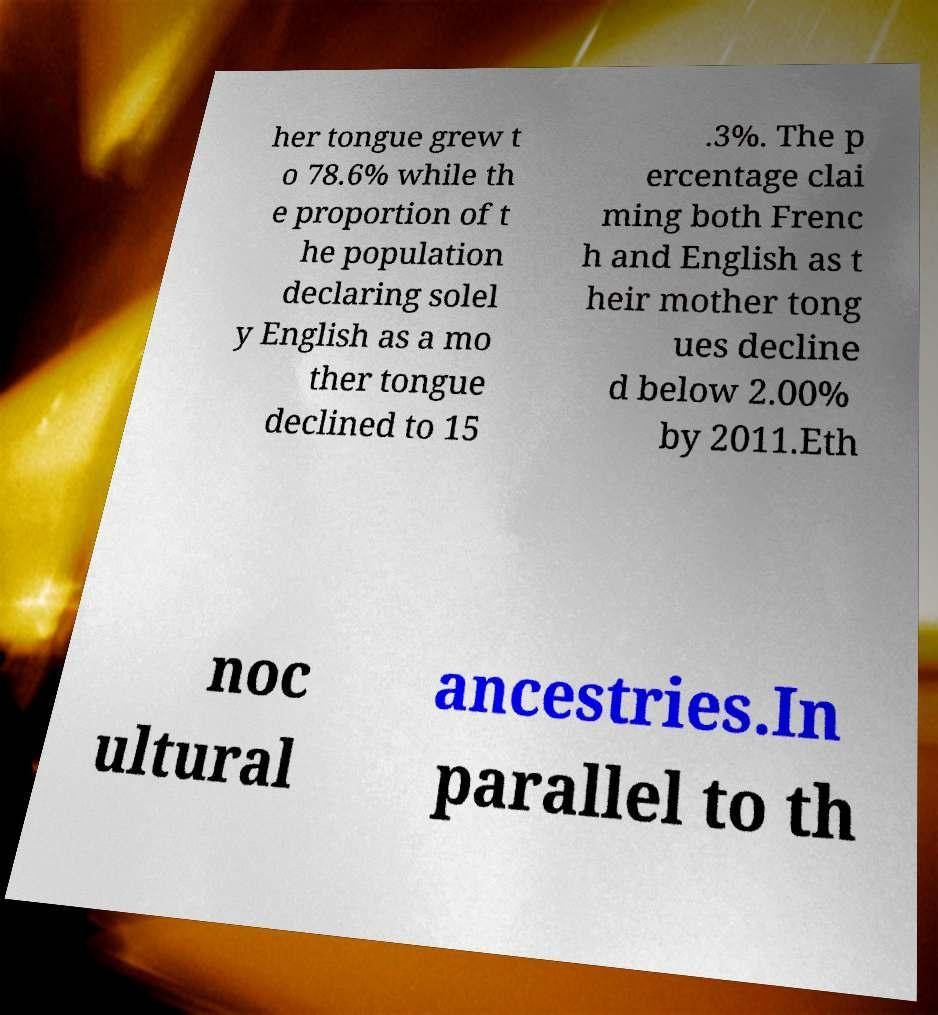Could you assist in decoding the text presented in this image and type it out clearly? her tongue grew t o 78.6% while th e proportion of t he population declaring solel y English as a mo ther tongue declined to 15 .3%. The p ercentage clai ming both Frenc h and English as t heir mother tong ues decline d below 2.00% by 2011.Eth noc ultural ancestries.In parallel to th 